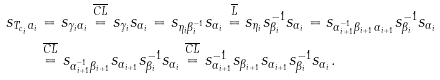Convert formula to latex. <formula><loc_0><loc_0><loc_500><loc_500>s _ { T _ { c _ { i } } a _ { i } } & = s _ { \gamma _ { i } \alpha _ { i } } \stackrel { \overline { C L } } { = } s _ { \gamma _ { i } } s _ { \alpha _ { i } } = s _ { \eta _ { i } \beta _ { i } ^ { - 1 } } s _ { \alpha _ { i } } \stackrel { \overline { L } } { = } s _ { \eta _ { i } } s _ { \beta _ { i } } ^ { - 1 } s _ { \alpha _ { i } } = s _ { \alpha _ { i + 1 } ^ { - 1 } \beta _ { i + 1 } \alpha _ { i + 1 } } s _ { \beta _ { i } } ^ { - 1 } s _ { \alpha _ { i } } \\ & \stackrel { \overline { C L } } { = } s _ { \alpha _ { i + 1 } ^ { - 1 } \beta _ { i + 1 } } s _ { \alpha _ { i + 1 } } s _ { \beta _ { i } } ^ { - 1 } s _ { \alpha _ { i } } \stackrel { \overline { C L } } { = } s _ { \alpha _ { i + 1 } } ^ { - 1 } s _ { \beta _ { i + 1 } } s _ { \alpha _ { i + 1 } } s _ { \beta _ { i } } ^ { - 1 } s _ { \alpha _ { i } } .</formula> 